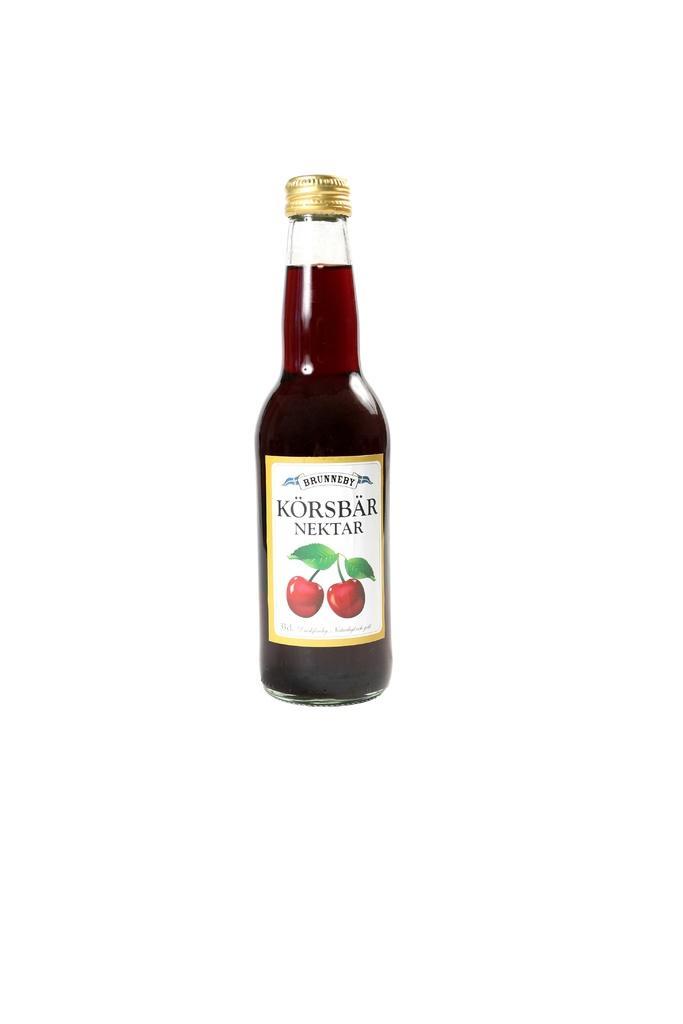Describe this image in one or two sentences. In this picture we can see bottle with drink in it and a sticker pasted to it and on sticker we can see two fruits. 